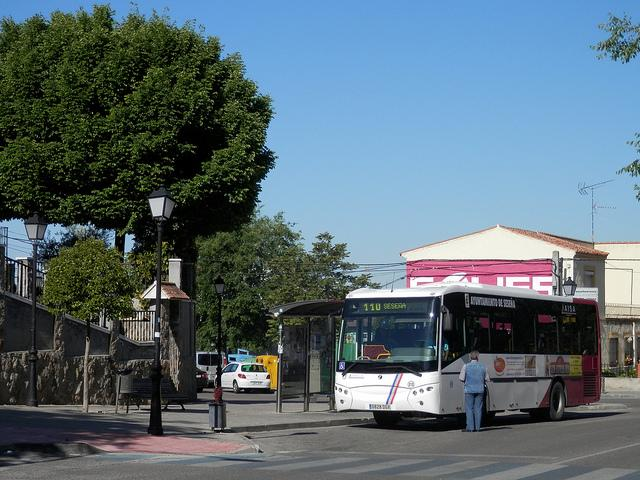During which weather would the bus stop here be most appreciated by riders?

Choices:
A) breezes
B) wind
C) clouds
D) rain rain 